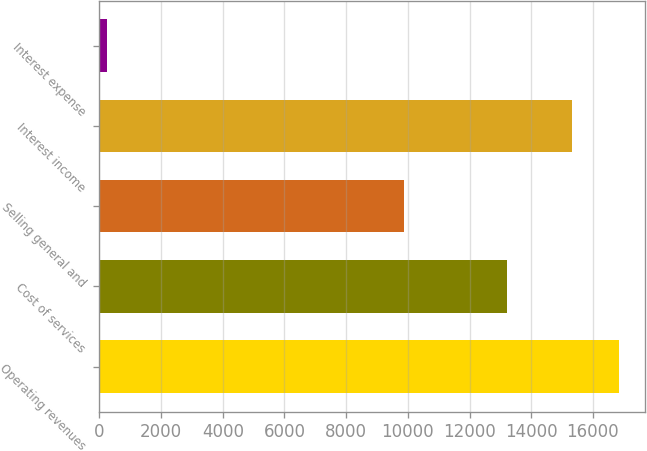Convert chart to OTSL. <chart><loc_0><loc_0><loc_500><loc_500><bar_chart><fcel>Operating revenues<fcel>Cost of services<fcel>Selling general and<fcel>Interest income<fcel>Interest expense<nl><fcel>16859.9<fcel>13225<fcel>9889<fcel>15327<fcel>259<nl></chart> 